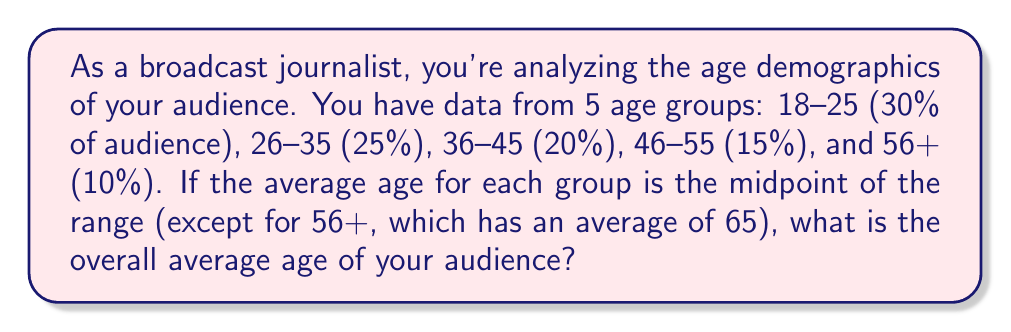Help me with this question. Let's approach this step-by-step:

1) First, let's determine the average age for each group:
   18-25: $(18+25)/2 = 21.5$
   26-35: $(26+35)/2 = 30.5$
   36-45: $(36+45)/2 = 40.5$
   46-55: $(46+55)/2 = 50.5$
   56+: Given as 65

2) Now, we need to calculate the weighted average. The formula is:

   $$\text{Weighted Average} = \sum_{i=1}^{n} w_i x_i$$

   where $w_i$ is the weight (percentage) and $x_i$ is the value (average age).

3) Let's substitute our values:

   $$\begin{align*}
   \text{Weighted Average} &= (0.30 \times 21.5) + (0.25 \times 30.5) + (0.20 \times 40.5) \\
   &+ (0.15 \times 50.5) + (0.10 \times 65)
   \end{align*}$$

4) Now, let's calculate:
   $$\begin{align*}
   &= 6.45 + 7.625 + 8.1 + 7.575 + 6.5 \\
   &= 36.25
   \end{align*}$$

Therefore, the overall average age of your audience is 36.25 years.
Answer: 36.25 years 